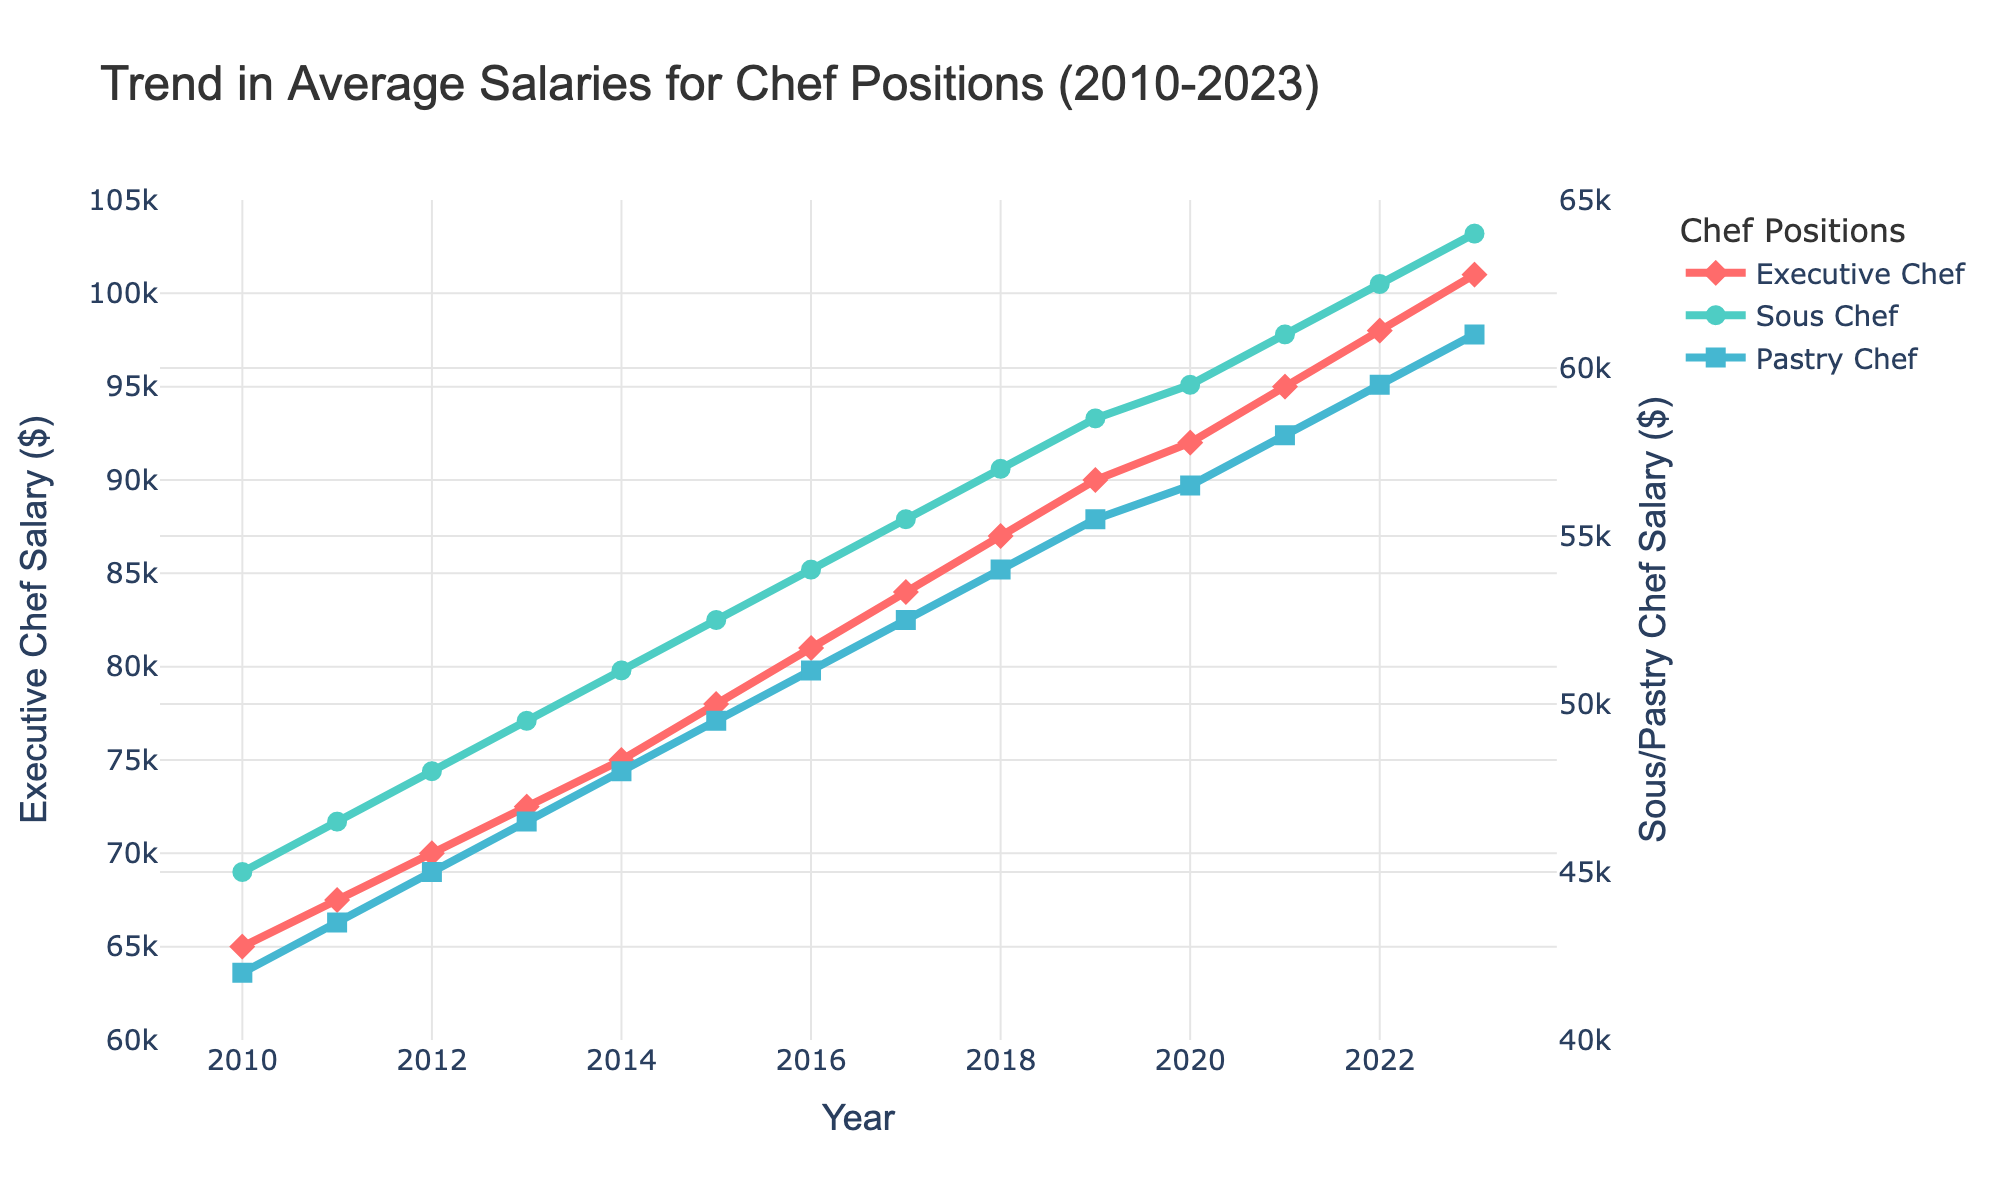What is the trend in the salary of Executive Chefs from 2010 to 2023? Executive Chef salaries show a consistent upward trend from 2010 ($65,000) to 2023 ($101,000). Each year, there is an increase in the salary.
Answer: Consistent upward trend Which year did the Pastry Chef salary surpass $50,000 for the first time? The Pastry Chef salary first surpassed $50,000 in 2016. In 2015, it was $49,500 and increased to $51,000 in 2016.
Answer: 2016 How much did the Sous Chef salary increase between 2010 and 2023? In 2010, the Sous Chef salary was $45,000, and by 2023, it had increased to $64,000. So, the increase is $64,000 - $45,000 = $19,000.
Answer: $19,000 Compare the salary increments between Executive Chef and Pastry Chef positions from 2010 to 2015. The Executive Chef salary increased from $65,000 to $78,000, which is an increase of $13,000. The Pastry Chef salary increased from $42,000 to $49,500, which is an increase of $7,500.
Answer: Executive Chef: $13,000, Pastry Chef: $7,500 What is the average salary of a Sous Chef over the entire period (2010-2023)? The salaries of Sous Chefs over the years are [$45,000, $46,500, $48,000, $49,500, $51,000, $52,500, $54,000, $55,500, $57,000, $58,500, $59,500, $61,000, $62,500, $64,000]. The sum of these values is $764,000. To find the average: $764,000 / 14 ≈ $54,571.43
Answer: Approximately $54,571.43 In which year was the salary difference between Executive Chefs and Pastry Chefs the largest? The salary difference between Executive Chefs and Pastry Chefs is largest in 2023. The Executive Chef salary is $101,000 and the Pastry Chef salary is $61,000, making the difference $40,000, which is the highest difference over the period.
Answer: 2023 Identify the years where the salaries of Sous Chefs and Pastry Chefs show the same growth rate. Both Sous Chef and Pastry Chef salaries increased every year. The years when both showed the same increment were 2016 and 2017 where both increased by $1,500 each year ($54,000 to $55,500 for Sous Chefs and $51,000 to $52,500 for Pastry Chefs).
Answer: 2016, 2017 How do the colors in the plot help differentiate between the chef positions? The colors used in the plot help distinguish the different chef positions: Executive Chef in red, Sous Chef in green, and Pastry Chef in blue, making it visually easy to identify each position's salary trend.
Answer: Different colors for each position 